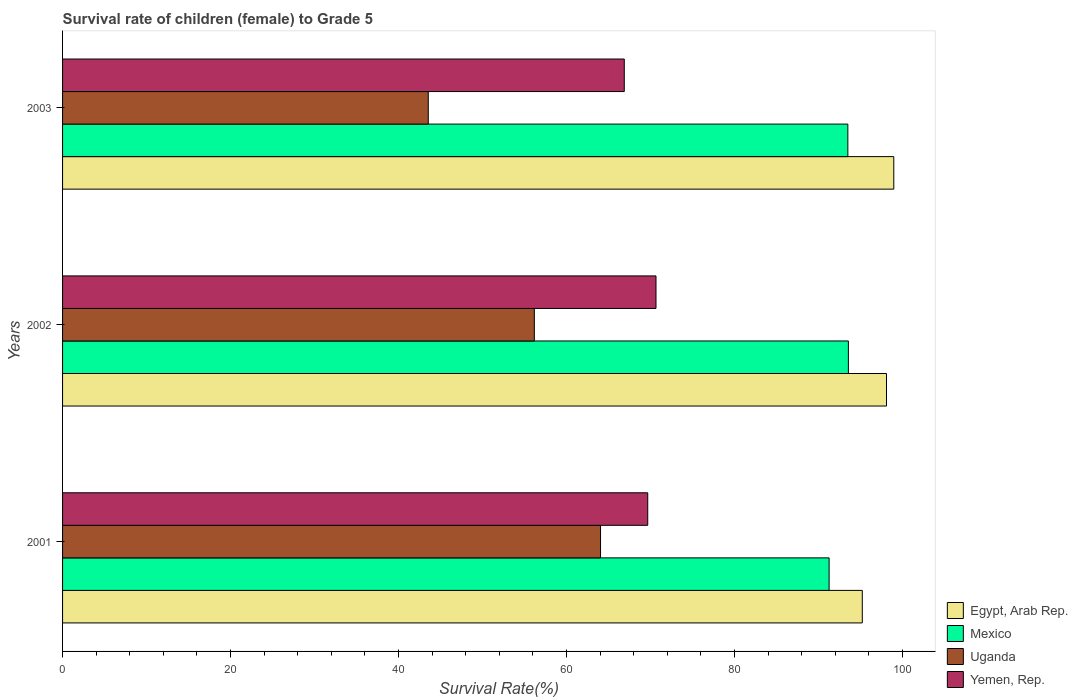How many different coloured bars are there?
Offer a very short reply. 4. Are the number of bars per tick equal to the number of legend labels?
Make the answer very short. Yes. In how many cases, is the number of bars for a given year not equal to the number of legend labels?
Your answer should be compact. 0. What is the survival rate of female children to grade 5 in Yemen, Rep. in 2001?
Your answer should be very brief. 69.67. Across all years, what is the maximum survival rate of female children to grade 5 in Uganda?
Provide a succinct answer. 64.05. Across all years, what is the minimum survival rate of female children to grade 5 in Uganda?
Provide a succinct answer. 43.54. What is the total survival rate of female children to grade 5 in Uganda in the graph?
Ensure brevity in your answer.  163.77. What is the difference between the survival rate of female children to grade 5 in Egypt, Arab Rep. in 2001 and that in 2003?
Give a very brief answer. -3.75. What is the difference between the survival rate of female children to grade 5 in Egypt, Arab Rep. in 2001 and the survival rate of female children to grade 5 in Mexico in 2003?
Your answer should be compact. 1.72. What is the average survival rate of female children to grade 5 in Mexico per year?
Give a very brief answer. 92.78. In the year 2003, what is the difference between the survival rate of female children to grade 5 in Egypt, Arab Rep. and survival rate of female children to grade 5 in Mexico?
Give a very brief answer. 5.47. What is the ratio of the survival rate of female children to grade 5 in Yemen, Rep. in 2001 to that in 2002?
Your response must be concise. 0.99. Is the survival rate of female children to grade 5 in Mexico in 2001 less than that in 2002?
Offer a very short reply. Yes. Is the difference between the survival rate of female children to grade 5 in Egypt, Arab Rep. in 2002 and 2003 greater than the difference between the survival rate of female children to grade 5 in Mexico in 2002 and 2003?
Make the answer very short. No. What is the difference between the highest and the second highest survival rate of female children to grade 5 in Mexico?
Offer a terse response. 0.06. What is the difference between the highest and the lowest survival rate of female children to grade 5 in Egypt, Arab Rep.?
Your response must be concise. 3.75. In how many years, is the survival rate of female children to grade 5 in Uganda greater than the average survival rate of female children to grade 5 in Uganda taken over all years?
Your response must be concise. 2. What does the 4th bar from the top in 2003 represents?
Give a very brief answer. Egypt, Arab Rep. Is it the case that in every year, the sum of the survival rate of female children to grade 5 in Egypt, Arab Rep. and survival rate of female children to grade 5 in Uganda is greater than the survival rate of female children to grade 5 in Mexico?
Your response must be concise. Yes. Are all the bars in the graph horizontal?
Ensure brevity in your answer.  Yes. Are the values on the major ticks of X-axis written in scientific E-notation?
Provide a succinct answer. No. Does the graph contain any zero values?
Your answer should be compact. No. Where does the legend appear in the graph?
Your answer should be very brief. Bottom right. What is the title of the graph?
Keep it short and to the point. Survival rate of children (female) to Grade 5. Does "Mongolia" appear as one of the legend labels in the graph?
Your answer should be very brief. No. What is the label or title of the X-axis?
Provide a short and direct response. Survival Rate(%). What is the label or title of the Y-axis?
Offer a terse response. Years. What is the Survival Rate(%) in Egypt, Arab Rep. in 2001?
Make the answer very short. 95.22. What is the Survival Rate(%) in Mexico in 2001?
Ensure brevity in your answer.  91.27. What is the Survival Rate(%) in Uganda in 2001?
Offer a very short reply. 64.05. What is the Survival Rate(%) in Yemen, Rep. in 2001?
Your response must be concise. 69.67. What is the Survival Rate(%) of Egypt, Arab Rep. in 2002?
Your answer should be very brief. 98.1. What is the Survival Rate(%) in Mexico in 2002?
Offer a terse response. 93.56. What is the Survival Rate(%) in Uganda in 2002?
Your response must be concise. 56.17. What is the Survival Rate(%) of Yemen, Rep. in 2002?
Offer a very short reply. 70.66. What is the Survival Rate(%) in Egypt, Arab Rep. in 2003?
Provide a short and direct response. 98.97. What is the Survival Rate(%) in Mexico in 2003?
Keep it short and to the point. 93.5. What is the Survival Rate(%) of Uganda in 2003?
Keep it short and to the point. 43.54. What is the Survival Rate(%) of Yemen, Rep. in 2003?
Your answer should be very brief. 66.88. Across all years, what is the maximum Survival Rate(%) of Egypt, Arab Rep.?
Your answer should be very brief. 98.97. Across all years, what is the maximum Survival Rate(%) in Mexico?
Keep it short and to the point. 93.56. Across all years, what is the maximum Survival Rate(%) in Uganda?
Keep it short and to the point. 64.05. Across all years, what is the maximum Survival Rate(%) in Yemen, Rep.?
Make the answer very short. 70.66. Across all years, what is the minimum Survival Rate(%) of Egypt, Arab Rep.?
Offer a terse response. 95.22. Across all years, what is the minimum Survival Rate(%) in Mexico?
Your answer should be very brief. 91.27. Across all years, what is the minimum Survival Rate(%) of Uganda?
Keep it short and to the point. 43.54. Across all years, what is the minimum Survival Rate(%) of Yemen, Rep.?
Provide a succinct answer. 66.88. What is the total Survival Rate(%) of Egypt, Arab Rep. in the graph?
Make the answer very short. 292.29. What is the total Survival Rate(%) of Mexico in the graph?
Ensure brevity in your answer.  278.33. What is the total Survival Rate(%) of Uganda in the graph?
Your answer should be compact. 163.77. What is the total Survival Rate(%) of Yemen, Rep. in the graph?
Your answer should be very brief. 207.21. What is the difference between the Survival Rate(%) of Egypt, Arab Rep. in 2001 and that in 2002?
Your response must be concise. -2.88. What is the difference between the Survival Rate(%) in Mexico in 2001 and that in 2002?
Provide a succinct answer. -2.29. What is the difference between the Survival Rate(%) of Uganda in 2001 and that in 2002?
Offer a very short reply. 7.88. What is the difference between the Survival Rate(%) in Yemen, Rep. in 2001 and that in 2002?
Offer a very short reply. -0.98. What is the difference between the Survival Rate(%) in Egypt, Arab Rep. in 2001 and that in 2003?
Offer a very short reply. -3.75. What is the difference between the Survival Rate(%) of Mexico in 2001 and that in 2003?
Provide a short and direct response. -2.23. What is the difference between the Survival Rate(%) in Uganda in 2001 and that in 2003?
Offer a very short reply. 20.51. What is the difference between the Survival Rate(%) of Yemen, Rep. in 2001 and that in 2003?
Your answer should be very brief. 2.79. What is the difference between the Survival Rate(%) in Egypt, Arab Rep. in 2002 and that in 2003?
Give a very brief answer. -0.87. What is the difference between the Survival Rate(%) in Mexico in 2002 and that in 2003?
Your answer should be compact. 0.06. What is the difference between the Survival Rate(%) of Uganda in 2002 and that in 2003?
Offer a terse response. 12.63. What is the difference between the Survival Rate(%) of Yemen, Rep. in 2002 and that in 2003?
Keep it short and to the point. 3.78. What is the difference between the Survival Rate(%) of Egypt, Arab Rep. in 2001 and the Survival Rate(%) of Mexico in 2002?
Your answer should be compact. 1.66. What is the difference between the Survival Rate(%) in Egypt, Arab Rep. in 2001 and the Survival Rate(%) in Uganda in 2002?
Your answer should be very brief. 39.05. What is the difference between the Survival Rate(%) in Egypt, Arab Rep. in 2001 and the Survival Rate(%) in Yemen, Rep. in 2002?
Your answer should be very brief. 24.56. What is the difference between the Survival Rate(%) in Mexico in 2001 and the Survival Rate(%) in Uganda in 2002?
Provide a succinct answer. 35.1. What is the difference between the Survival Rate(%) of Mexico in 2001 and the Survival Rate(%) of Yemen, Rep. in 2002?
Offer a very short reply. 20.61. What is the difference between the Survival Rate(%) of Uganda in 2001 and the Survival Rate(%) of Yemen, Rep. in 2002?
Offer a very short reply. -6.6. What is the difference between the Survival Rate(%) of Egypt, Arab Rep. in 2001 and the Survival Rate(%) of Mexico in 2003?
Make the answer very short. 1.72. What is the difference between the Survival Rate(%) of Egypt, Arab Rep. in 2001 and the Survival Rate(%) of Uganda in 2003?
Provide a short and direct response. 51.68. What is the difference between the Survival Rate(%) in Egypt, Arab Rep. in 2001 and the Survival Rate(%) in Yemen, Rep. in 2003?
Offer a very short reply. 28.34. What is the difference between the Survival Rate(%) in Mexico in 2001 and the Survival Rate(%) in Uganda in 2003?
Your answer should be very brief. 47.73. What is the difference between the Survival Rate(%) of Mexico in 2001 and the Survival Rate(%) of Yemen, Rep. in 2003?
Make the answer very short. 24.39. What is the difference between the Survival Rate(%) in Uganda in 2001 and the Survival Rate(%) in Yemen, Rep. in 2003?
Give a very brief answer. -2.83. What is the difference between the Survival Rate(%) in Egypt, Arab Rep. in 2002 and the Survival Rate(%) in Mexico in 2003?
Keep it short and to the point. 4.6. What is the difference between the Survival Rate(%) of Egypt, Arab Rep. in 2002 and the Survival Rate(%) of Uganda in 2003?
Give a very brief answer. 54.56. What is the difference between the Survival Rate(%) in Egypt, Arab Rep. in 2002 and the Survival Rate(%) in Yemen, Rep. in 2003?
Offer a terse response. 31.22. What is the difference between the Survival Rate(%) in Mexico in 2002 and the Survival Rate(%) in Uganda in 2003?
Provide a succinct answer. 50.02. What is the difference between the Survival Rate(%) of Mexico in 2002 and the Survival Rate(%) of Yemen, Rep. in 2003?
Your response must be concise. 26.68. What is the difference between the Survival Rate(%) of Uganda in 2002 and the Survival Rate(%) of Yemen, Rep. in 2003?
Provide a short and direct response. -10.71. What is the average Survival Rate(%) of Egypt, Arab Rep. per year?
Give a very brief answer. 97.43. What is the average Survival Rate(%) of Mexico per year?
Give a very brief answer. 92.78. What is the average Survival Rate(%) in Uganda per year?
Provide a succinct answer. 54.59. What is the average Survival Rate(%) in Yemen, Rep. per year?
Your response must be concise. 69.07. In the year 2001, what is the difference between the Survival Rate(%) of Egypt, Arab Rep. and Survival Rate(%) of Mexico?
Offer a very short reply. 3.95. In the year 2001, what is the difference between the Survival Rate(%) in Egypt, Arab Rep. and Survival Rate(%) in Uganda?
Provide a succinct answer. 31.17. In the year 2001, what is the difference between the Survival Rate(%) in Egypt, Arab Rep. and Survival Rate(%) in Yemen, Rep.?
Ensure brevity in your answer.  25.55. In the year 2001, what is the difference between the Survival Rate(%) of Mexico and Survival Rate(%) of Uganda?
Ensure brevity in your answer.  27.22. In the year 2001, what is the difference between the Survival Rate(%) in Mexico and Survival Rate(%) in Yemen, Rep.?
Your response must be concise. 21.59. In the year 2001, what is the difference between the Survival Rate(%) in Uganda and Survival Rate(%) in Yemen, Rep.?
Offer a terse response. -5.62. In the year 2002, what is the difference between the Survival Rate(%) in Egypt, Arab Rep. and Survival Rate(%) in Mexico?
Offer a terse response. 4.54. In the year 2002, what is the difference between the Survival Rate(%) of Egypt, Arab Rep. and Survival Rate(%) of Uganda?
Provide a short and direct response. 41.93. In the year 2002, what is the difference between the Survival Rate(%) of Egypt, Arab Rep. and Survival Rate(%) of Yemen, Rep.?
Ensure brevity in your answer.  27.44. In the year 2002, what is the difference between the Survival Rate(%) of Mexico and Survival Rate(%) of Uganda?
Provide a succinct answer. 37.39. In the year 2002, what is the difference between the Survival Rate(%) in Mexico and Survival Rate(%) in Yemen, Rep.?
Ensure brevity in your answer.  22.91. In the year 2002, what is the difference between the Survival Rate(%) in Uganda and Survival Rate(%) in Yemen, Rep.?
Give a very brief answer. -14.49. In the year 2003, what is the difference between the Survival Rate(%) in Egypt, Arab Rep. and Survival Rate(%) in Mexico?
Your response must be concise. 5.47. In the year 2003, what is the difference between the Survival Rate(%) of Egypt, Arab Rep. and Survival Rate(%) of Uganda?
Your response must be concise. 55.43. In the year 2003, what is the difference between the Survival Rate(%) of Egypt, Arab Rep. and Survival Rate(%) of Yemen, Rep.?
Keep it short and to the point. 32.09. In the year 2003, what is the difference between the Survival Rate(%) in Mexico and Survival Rate(%) in Uganda?
Offer a terse response. 49.96. In the year 2003, what is the difference between the Survival Rate(%) of Mexico and Survival Rate(%) of Yemen, Rep.?
Provide a short and direct response. 26.62. In the year 2003, what is the difference between the Survival Rate(%) of Uganda and Survival Rate(%) of Yemen, Rep.?
Ensure brevity in your answer.  -23.34. What is the ratio of the Survival Rate(%) of Egypt, Arab Rep. in 2001 to that in 2002?
Offer a terse response. 0.97. What is the ratio of the Survival Rate(%) in Mexico in 2001 to that in 2002?
Keep it short and to the point. 0.98. What is the ratio of the Survival Rate(%) of Uganda in 2001 to that in 2002?
Give a very brief answer. 1.14. What is the ratio of the Survival Rate(%) of Yemen, Rep. in 2001 to that in 2002?
Offer a terse response. 0.99. What is the ratio of the Survival Rate(%) in Egypt, Arab Rep. in 2001 to that in 2003?
Your response must be concise. 0.96. What is the ratio of the Survival Rate(%) in Mexico in 2001 to that in 2003?
Your response must be concise. 0.98. What is the ratio of the Survival Rate(%) in Uganda in 2001 to that in 2003?
Give a very brief answer. 1.47. What is the ratio of the Survival Rate(%) of Yemen, Rep. in 2001 to that in 2003?
Offer a very short reply. 1.04. What is the ratio of the Survival Rate(%) in Egypt, Arab Rep. in 2002 to that in 2003?
Offer a terse response. 0.99. What is the ratio of the Survival Rate(%) of Mexico in 2002 to that in 2003?
Your answer should be compact. 1. What is the ratio of the Survival Rate(%) of Uganda in 2002 to that in 2003?
Keep it short and to the point. 1.29. What is the ratio of the Survival Rate(%) in Yemen, Rep. in 2002 to that in 2003?
Give a very brief answer. 1.06. What is the difference between the highest and the second highest Survival Rate(%) in Egypt, Arab Rep.?
Give a very brief answer. 0.87. What is the difference between the highest and the second highest Survival Rate(%) in Mexico?
Give a very brief answer. 0.06. What is the difference between the highest and the second highest Survival Rate(%) in Uganda?
Ensure brevity in your answer.  7.88. What is the difference between the highest and the second highest Survival Rate(%) of Yemen, Rep.?
Provide a succinct answer. 0.98. What is the difference between the highest and the lowest Survival Rate(%) in Egypt, Arab Rep.?
Keep it short and to the point. 3.75. What is the difference between the highest and the lowest Survival Rate(%) in Mexico?
Your answer should be compact. 2.29. What is the difference between the highest and the lowest Survival Rate(%) in Uganda?
Give a very brief answer. 20.51. What is the difference between the highest and the lowest Survival Rate(%) in Yemen, Rep.?
Provide a succinct answer. 3.78. 